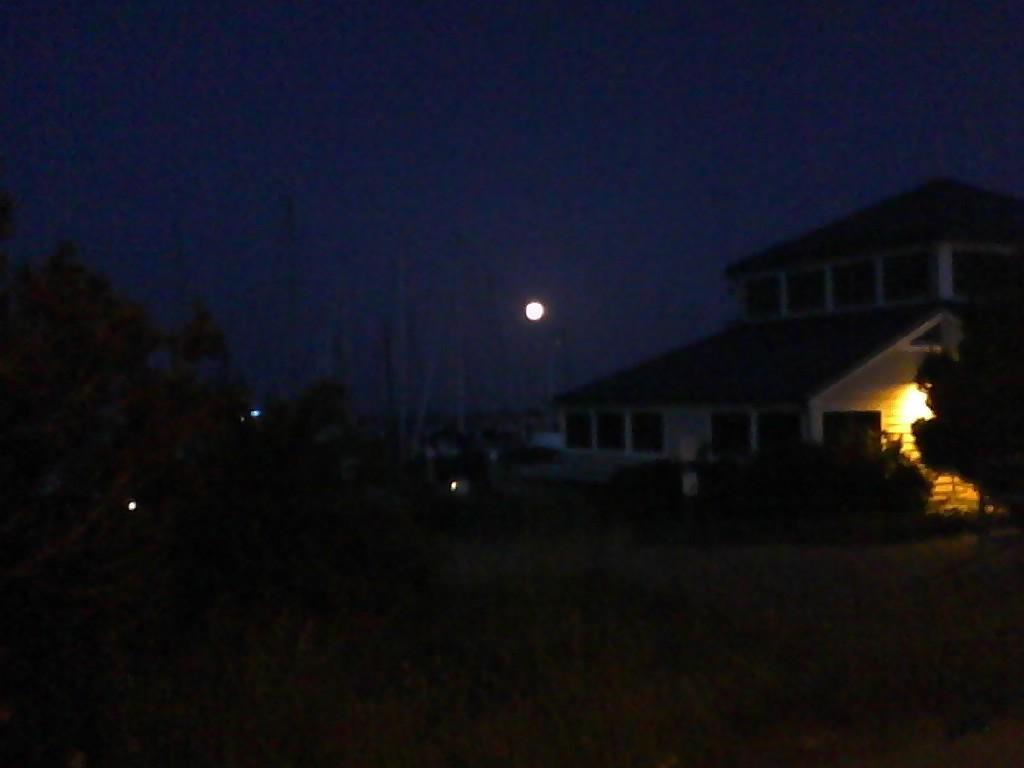How would you summarize this image in a sentence or two? In this image there are trees, building. In the sky there is moon. This is night time. 